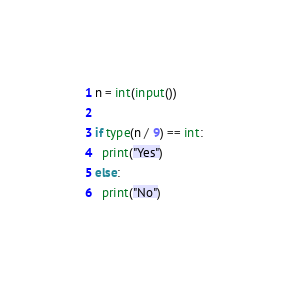Convert code to text. <code><loc_0><loc_0><loc_500><loc_500><_Python_>n = int(input())

if type(n / 9) == int:
  print("Yes")
else:
  print("No")</code> 